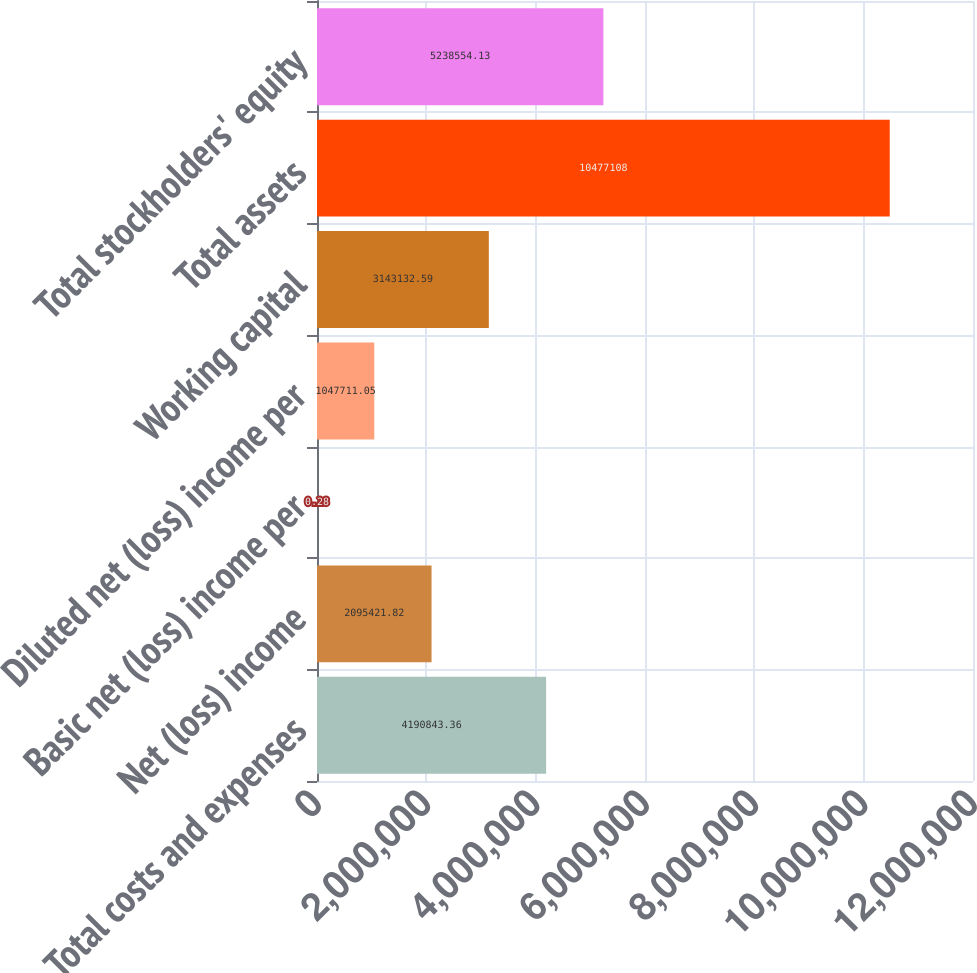<chart> <loc_0><loc_0><loc_500><loc_500><bar_chart><fcel>Total costs and expenses<fcel>Net (loss) income<fcel>Basic net (loss) income per<fcel>Diluted net (loss) income per<fcel>Working capital<fcel>Total assets<fcel>Total stockholders' equity<nl><fcel>4.19084e+06<fcel>2.09542e+06<fcel>0.28<fcel>1.04771e+06<fcel>3.14313e+06<fcel>1.04771e+07<fcel>5.23855e+06<nl></chart> 